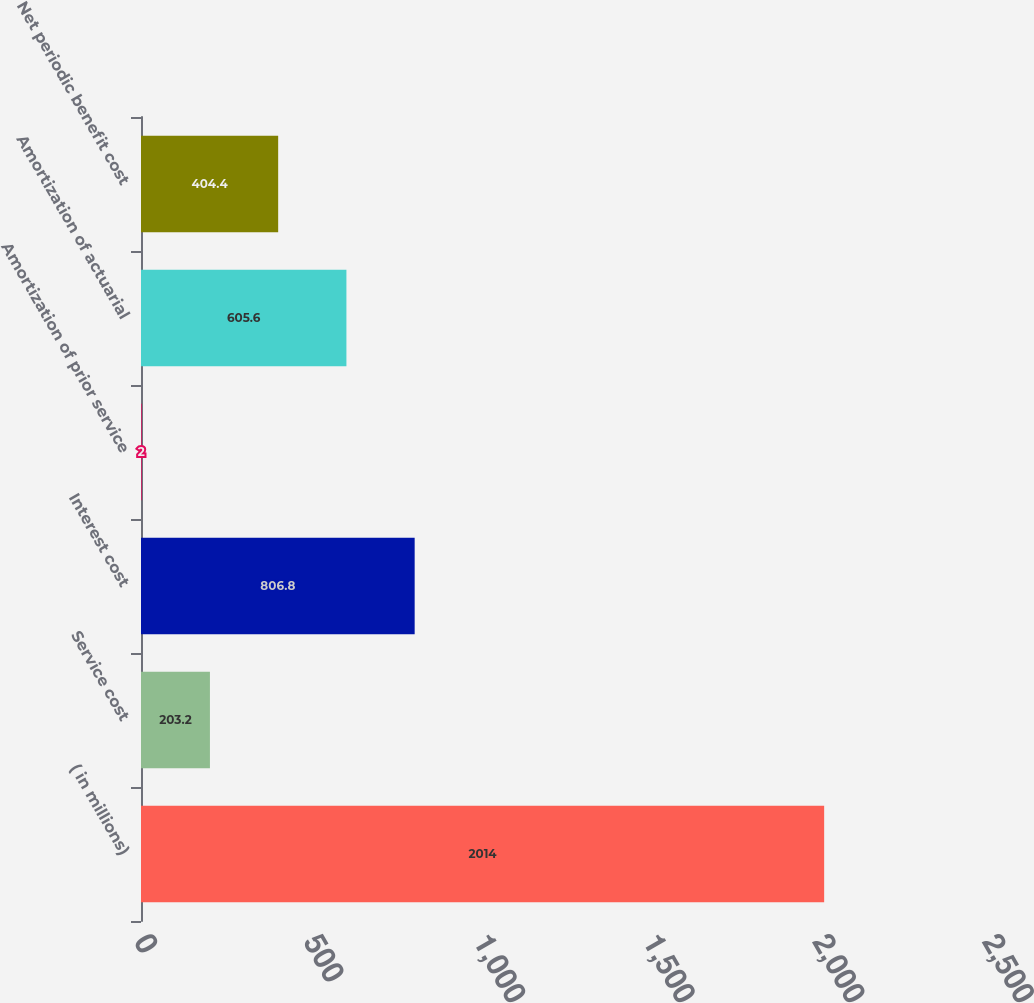<chart> <loc_0><loc_0><loc_500><loc_500><bar_chart><fcel>( in millions)<fcel>Service cost<fcel>Interest cost<fcel>Amortization of prior service<fcel>Amortization of actuarial<fcel>Net periodic benefit cost<nl><fcel>2014<fcel>203.2<fcel>806.8<fcel>2<fcel>605.6<fcel>404.4<nl></chart> 